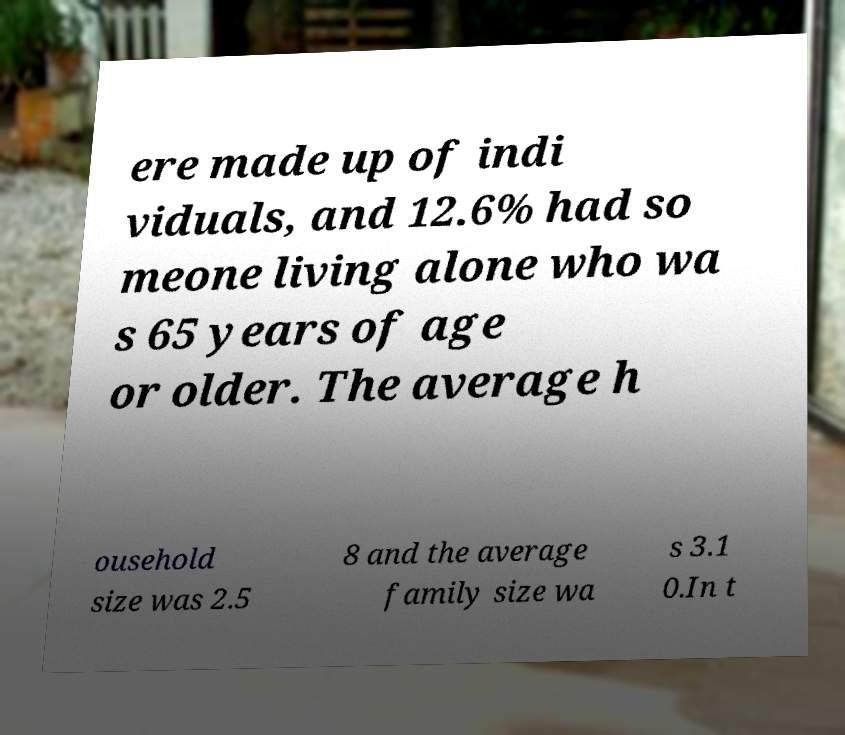Please read and relay the text visible in this image. What does it say? ere made up of indi viduals, and 12.6% had so meone living alone who wa s 65 years of age or older. The average h ousehold size was 2.5 8 and the average family size wa s 3.1 0.In t 